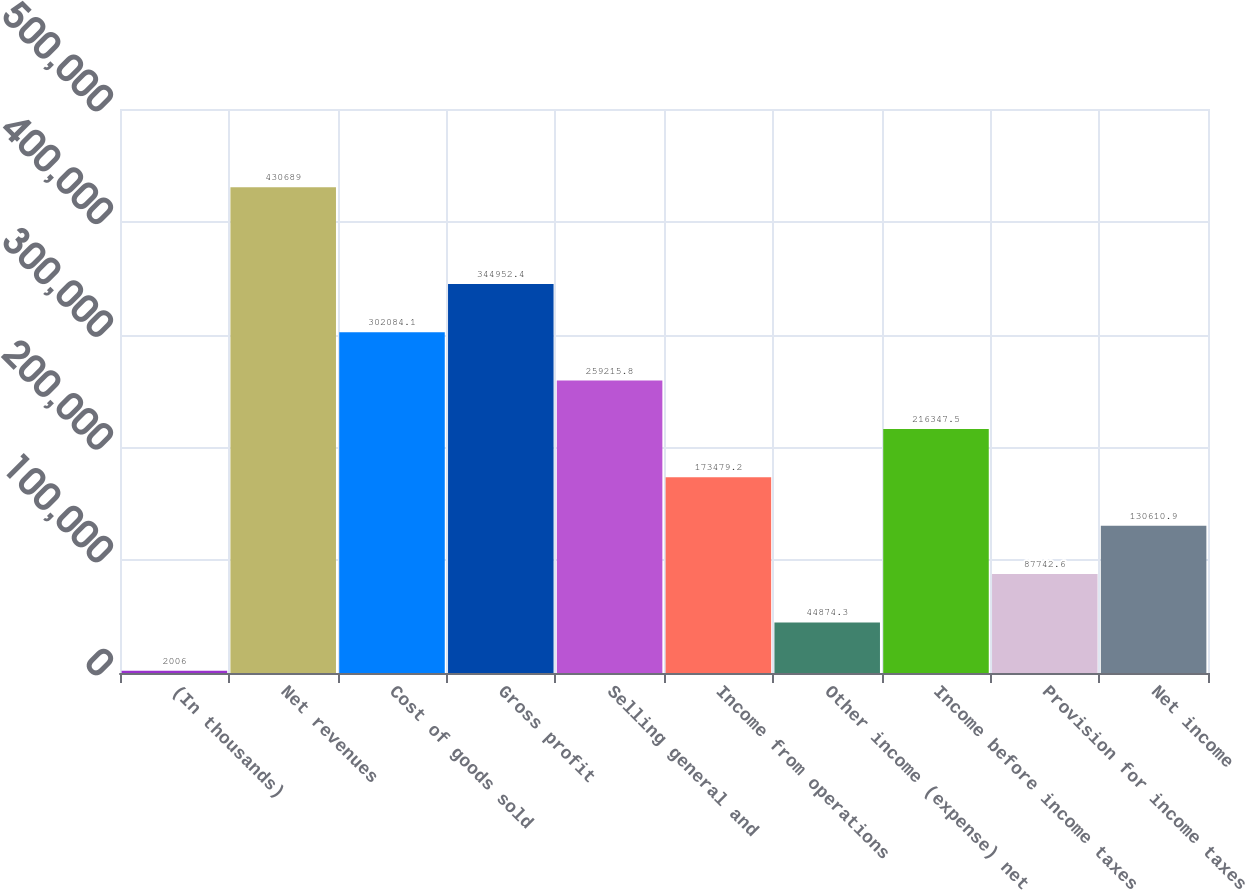Convert chart to OTSL. <chart><loc_0><loc_0><loc_500><loc_500><bar_chart><fcel>(In thousands)<fcel>Net revenues<fcel>Cost of goods sold<fcel>Gross profit<fcel>Selling general and<fcel>Income from operations<fcel>Other income (expense) net<fcel>Income before income taxes<fcel>Provision for income taxes<fcel>Net income<nl><fcel>2006<fcel>430689<fcel>302084<fcel>344952<fcel>259216<fcel>173479<fcel>44874.3<fcel>216348<fcel>87742.6<fcel>130611<nl></chart> 